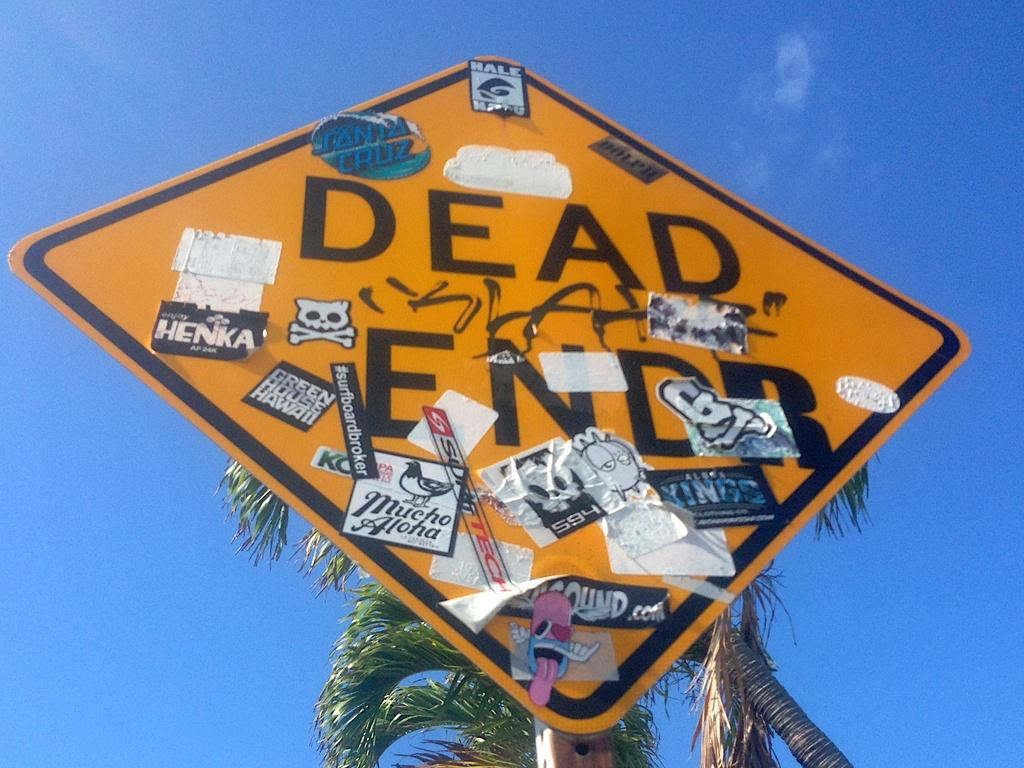<image>
Provide a brief description of the given image. A dead end road sign covered in stickers and paint. 